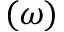Convert formula to latex. <formula><loc_0><loc_0><loc_500><loc_500>( \omega )</formula> 